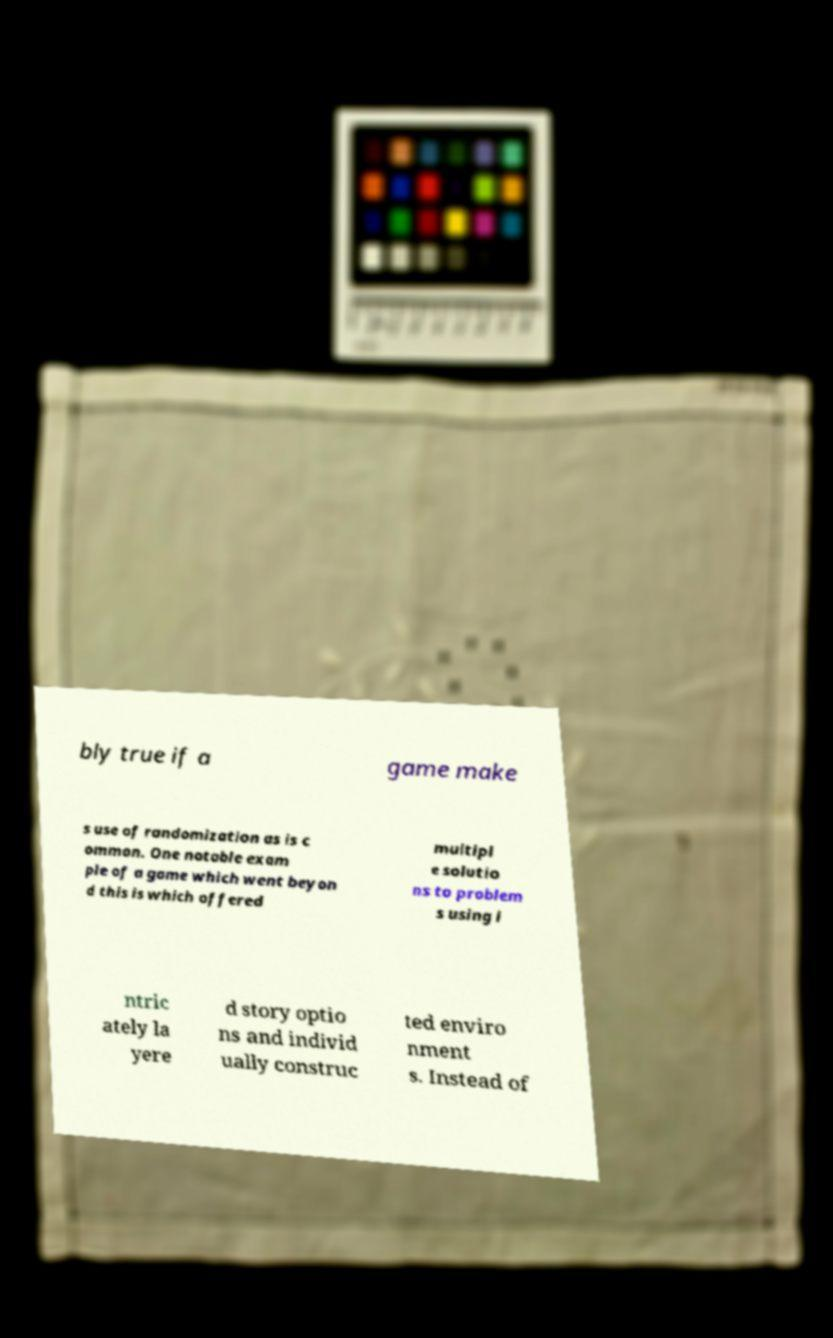I need the written content from this picture converted into text. Can you do that? bly true if a game make s use of randomization as is c ommon. One notable exam ple of a game which went beyon d this is which offered multipl e solutio ns to problem s using i ntric ately la yere d story optio ns and individ ually construc ted enviro nment s. Instead of 